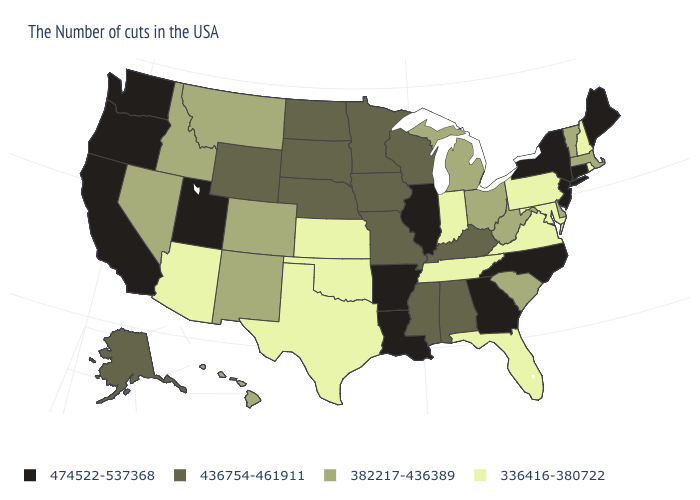Does Connecticut have a lower value than Oregon?
Answer briefly. No. What is the value of Colorado?
Give a very brief answer. 382217-436389. Among the states that border Delaware , which have the highest value?
Answer briefly. New Jersey. Among the states that border New Jersey , which have the lowest value?
Short answer required. Pennsylvania. Is the legend a continuous bar?
Quick response, please. No. Which states have the lowest value in the USA?
Keep it brief. Rhode Island, New Hampshire, Maryland, Pennsylvania, Virginia, Florida, Indiana, Tennessee, Kansas, Oklahoma, Texas, Arizona. What is the value of Utah?
Give a very brief answer. 474522-537368. Does Illinois have the highest value in the MidWest?
Quick response, please. Yes. Name the states that have a value in the range 382217-436389?
Short answer required. Massachusetts, Vermont, Delaware, South Carolina, West Virginia, Ohio, Michigan, Colorado, New Mexico, Montana, Idaho, Nevada, Hawaii. What is the value of New Mexico?
Give a very brief answer. 382217-436389. Name the states that have a value in the range 382217-436389?
Answer briefly. Massachusetts, Vermont, Delaware, South Carolina, West Virginia, Ohio, Michigan, Colorado, New Mexico, Montana, Idaho, Nevada, Hawaii. What is the value of Louisiana?
Answer briefly. 474522-537368. What is the value of New Hampshire?
Quick response, please. 336416-380722. How many symbols are there in the legend?
Be succinct. 4. What is the value of Montana?
Write a very short answer. 382217-436389. 